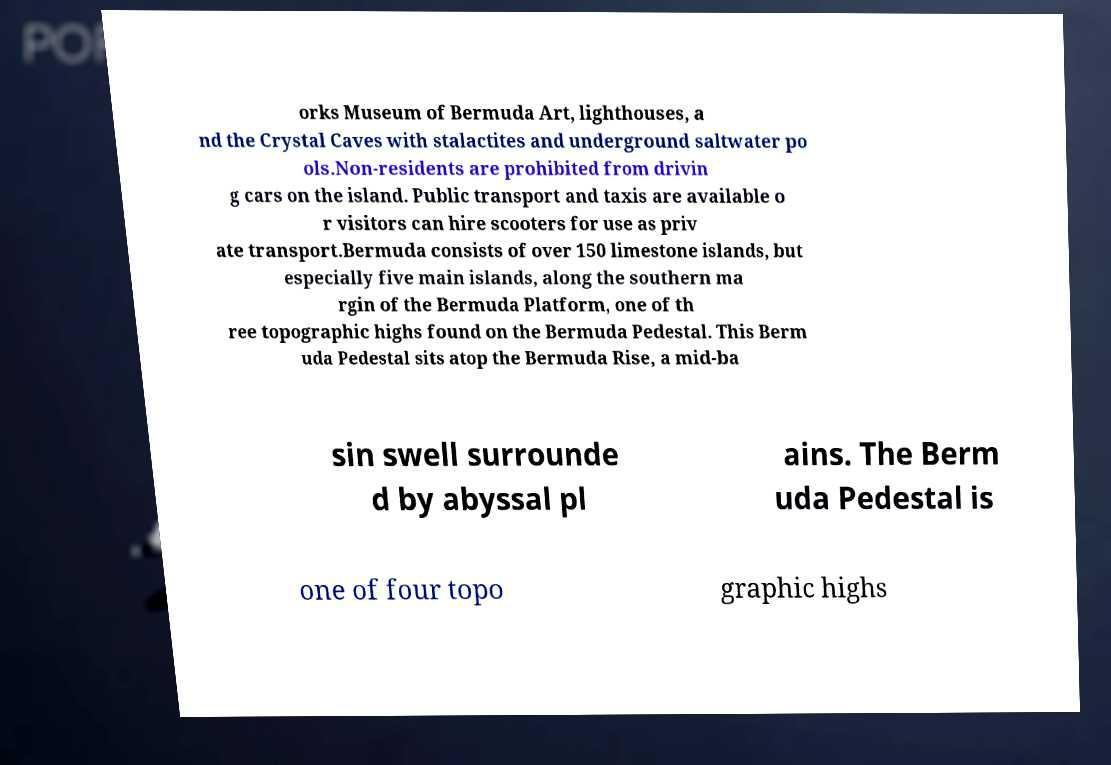There's text embedded in this image that I need extracted. Can you transcribe it verbatim? orks Museum of Bermuda Art, lighthouses, a nd the Crystal Caves with stalactites and underground saltwater po ols.Non-residents are prohibited from drivin g cars on the island. Public transport and taxis are available o r visitors can hire scooters for use as priv ate transport.Bermuda consists of over 150 limestone islands, but especially five main islands, along the southern ma rgin of the Bermuda Platform, one of th ree topographic highs found on the Bermuda Pedestal. This Berm uda Pedestal sits atop the Bermuda Rise, a mid-ba sin swell surrounde d by abyssal pl ains. The Berm uda Pedestal is one of four topo graphic highs 